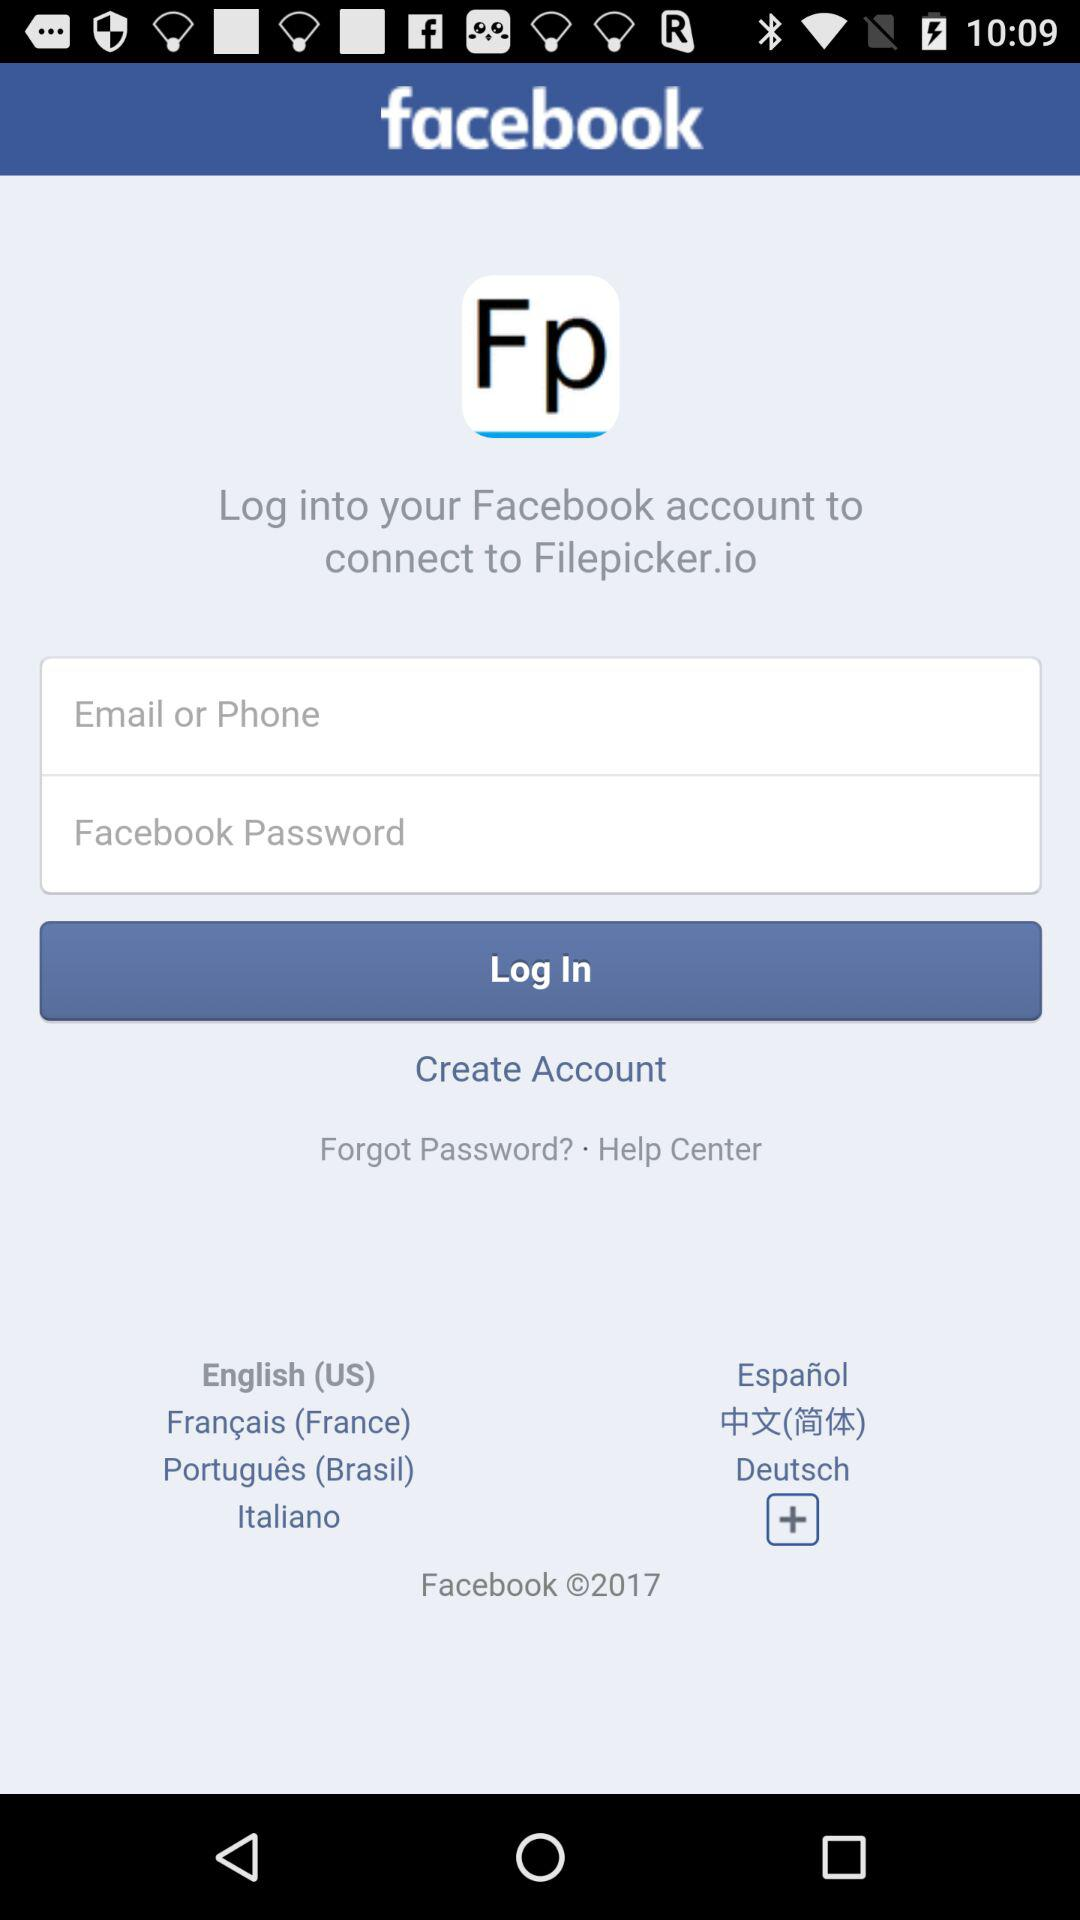How many text inputs are there for logging in?
Answer the question using a single word or phrase. 2 